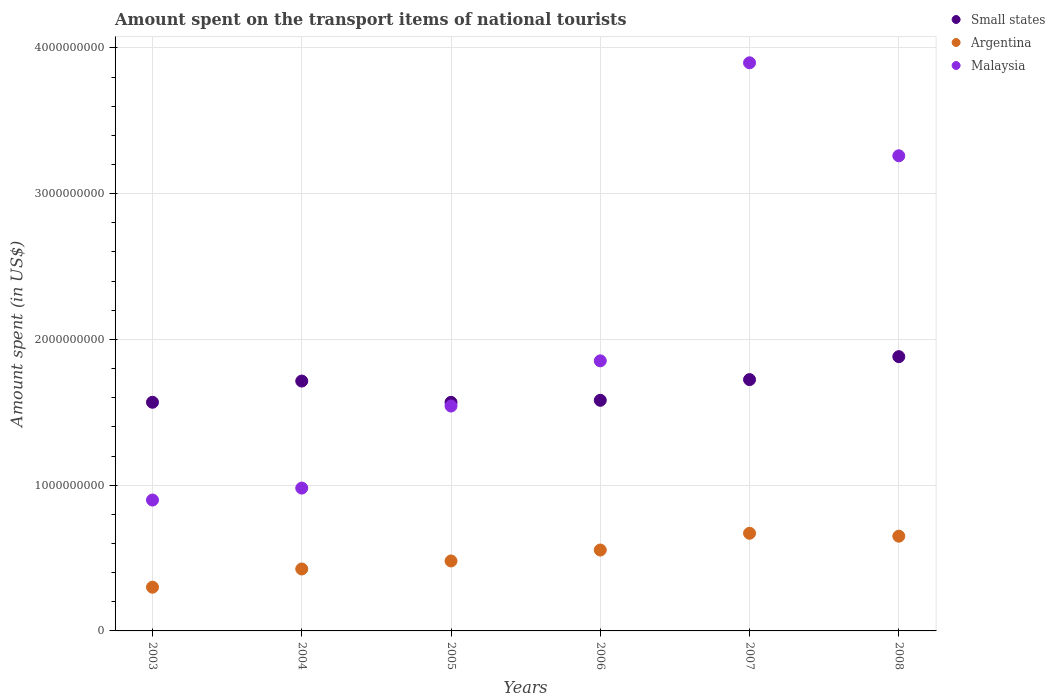What is the amount spent on the transport items of national tourists in Malaysia in 2005?
Your response must be concise. 1.54e+09. Across all years, what is the maximum amount spent on the transport items of national tourists in Small states?
Ensure brevity in your answer.  1.88e+09. Across all years, what is the minimum amount spent on the transport items of national tourists in Small states?
Ensure brevity in your answer.  1.57e+09. In which year was the amount spent on the transport items of national tourists in Argentina maximum?
Give a very brief answer. 2007. What is the total amount spent on the transport items of national tourists in Malaysia in the graph?
Keep it short and to the point. 1.24e+1. What is the difference between the amount spent on the transport items of national tourists in Small states in 2005 and that in 2008?
Offer a terse response. -3.14e+08. What is the difference between the amount spent on the transport items of national tourists in Argentina in 2006 and the amount spent on the transport items of national tourists in Small states in 2003?
Give a very brief answer. -1.01e+09. What is the average amount spent on the transport items of national tourists in Small states per year?
Keep it short and to the point. 1.67e+09. In the year 2005, what is the difference between the amount spent on the transport items of national tourists in Small states and amount spent on the transport items of national tourists in Argentina?
Give a very brief answer. 1.09e+09. What is the ratio of the amount spent on the transport items of national tourists in Malaysia in 2003 to that in 2006?
Provide a short and direct response. 0.48. Is the amount spent on the transport items of national tourists in Small states in 2003 less than that in 2007?
Offer a terse response. Yes. Is the difference between the amount spent on the transport items of national tourists in Small states in 2005 and 2007 greater than the difference between the amount spent on the transport items of national tourists in Argentina in 2005 and 2007?
Offer a very short reply. Yes. What is the difference between the highest and the lowest amount spent on the transport items of national tourists in Small states?
Provide a succinct answer. 3.14e+08. Is it the case that in every year, the sum of the amount spent on the transport items of national tourists in Small states and amount spent on the transport items of national tourists in Malaysia  is greater than the amount spent on the transport items of national tourists in Argentina?
Offer a very short reply. Yes. Does the amount spent on the transport items of national tourists in Argentina monotonically increase over the years?
Make the answer very short. No. Is the amount spent on the transport items of national tourists in Argentina strictly greater than the amount spent on the transport items of national tourists in Malaysia over the years?
Ensure brevity in your answer.  No. Is the amount spent on the transport items of national tourists in Argentina strictly less than the amount spent on the transport items of national tourists in Small states over the years?
Your answer should be compact. Yes. How many dotlines are there?
Make the answer very short. 3. Does the graph contain any zero values?
Ensure brevity in your answer.  No. Where does the legend appear in the graph?
Provide a succinct answer. Top right. How many legend labels are there?
Provide a succinct answer. 3. How are the legend labels stacked?
Your answer should be compact. Vertical. What is the title of the graph?
Provide a short and direct response. Amount spent on the transport items of national tourists. What is the label or title of the X-axis?
Provide a short and direct response. Years. What is the label or title of the Y-axis?
Give a very brief answer. Amount spent (in US$). What is the Amount spent (in US$) in Small states in 2003?
Provide a short and direct response. 1.57e+09. What is the Amount spent (in US$) in Argentina in 2003?
Your answer should be compact. 3.00e+08. What is the Amount spent (in US$) in Malaysia in 2003?
Provide a succinct answer. 8.98e+08. What is the Amount spent (in US$) of Small states in 2004?
Your response must be concise. 1.71e+09. What is the Amount spent (in US$) of Argentina in 2004?
Make the answer very short. 4.25e+08. What is the Amount spent (in US$) of Malaysia in 2004?
Your answer should be very brief. 9.80e+08. What is the Amount spent (in US$) in Small states in 2005?
Your response must be concise. 1.57e+09. What is the Amount spent (in US$) of Argentina in 2005?
Offer a terse response. 4.80e+08. What is the Amount spent (in US$) of Malaysia in 2005?
Ensure brevity in your answer.  1.54e+09. What is the Amount spent (in US$) in Small states in 2006?
Keep it short and to the point. 1.58e+09. What is the Amount spent (in US$) of Argentina in 2006?
Provide a succinct answer. 5.55e+08. What is the Amount spent (in US$) of Malaysia in 2006?
Your response must be concise. 1.85e+09. What is the Amount spent (in US$) of Small states in 2007?
Provide a succinct answer. 1.72e+09. What is the Amount spent (in US$) of Argentina in 2007?
Your answer should be very brief. 6.70e+08. What is the Amount spent (in US$) in Malaysia in 2007?
Make the answer very short. 3.90e+09. What is the Amount spent (in US$) in Small states in 2008?
Ensure brevity in your answer.  1.88e+09. What is the Amount spent (in US$) in Argentina in 2008?
Your answer should be very brief. 6.50e+08. What is the Amount spent (in US$) in Malaysia in 2008?
Keep it short and to the point. 3.26e+09. Across all years, what is the maximum Amount spent (in US$) in Small states?
Make the answer very short. 1.88e+09. Across all years, what is the maximum Amount spent (in US$) of Argentina?
Your answer should be compact. 6.70e+08. Across all years, what is the maximum Amount spent (in US$) in Malaysia?
Provide a short and direct response. 3.90e+09. Across all years, what is the minimum Amount spent (in US$) in Small states?
Offer a terse response. 1.57e+09. Across all years, what is the minimum Amount spent (in US$) in Argentina?
Give a very brief answer. 3.00e+08. Across all years, what is the minimum Amount spent (in US$) in Malaysia?
Provide a succinct answer. 8.98e+08. What is the total Amount spent (in US$) of Small states in the graph?
Give a very brief answer. 1.00e+1. What is the total Amount spent (in US$) of Argentina in the graph?
Provide a succinct answer. 3.08e+09. What is the total Amount spent (in US$) of Malaysia in the graph?
Your answer should be compact. 1.24e+1. What is the difference between the Amount spent (in US$) of Small states in 2003 and that in 2004?
Your response must be concise. -1.45e+08. What is the difference between the Amount spent (in US$) in Argentina in 2003 and that in 2004?
Give a very brief answer. -1.25e+08. What is the difference between the Amount spent (in US$) in Malaysia in 2003 and that in 2004?
Offer a terse response. -8.20e+07. What is the difference between the Amount spent (in US$) of Small states in 2003 and that in 2005?
Make the answer very short. 5.74e+05. What is the difference between the Amount spent (in US$) of Argentina in 2003 and that in 2005?
Offer a terse response. -1.80e+08. What is the difference between the Amount spent (in US$) of Malaysia in 2003 and that in 2005?
Make the answer very short. -6.45e+08. What is the difference between the Amount spent (in US$) of Small states in 2003 and that in 2006?
Make the answer very short. -1.35e+07. What is the difference between the Amount spent (in US$) of Argentina in 2003 and that in 2006?
Provide a short and direct response. -2.55e+08. What is the difference between the Amount spent (in US$) of Malaysia in 2003 and that in 2006?
Keep it short and to the point. -9.55e+08. What is the difference between the Amount spent (in US$) of Small states in 2003 and that in 2007?
Provide a succinct answer. -1.55e+08. What is the difference between the Amount spent (in US$) in Argentina in 2003 and that in 2007?
Your response must be concise. -3.70e+08. What is the difference between the Amount spent (in US$) in Malaysia in 2003 and that in 2007?
Ensure brevity in your answer.  -3.00e+09. What is the difference between the Amount spent (in US$) of Small states in 2003 and that in 2008?
Provide a succinct answer. -3.13e+08. What is the difference between the Amount spent (in US$) in Argentina in 2003 and that in 2008?
Give a very brief answer. -3.50e+08. What is the difference between the Amount spent (in US$) of Malaysia in 2003 and that in 2008?
Your response must be concise. -2.36e+09. What is the difference between the Amount spent (in US$) of Small states in 2004 and that in 2005?
Provide a short and direct response. 1.46e+08. What is the difference between the Amount spent (in US$) of Argentina in 2004 and that in 2005?
Ensure brevity in your answer.  -5.50e+07. What is the difference between the Amount spent (in US$) in Malaysia in 2004 and that in 2005?
Provide a succinct answer. -5.63e+08. What is the difference between the Amount spent (in US$) in Small states in 2004 and that in 2006?
Keep it short and to the point. 1.32e+08. What is the difference between the Amount spent (in US$) in Argentina in 2004 and that in 2006?
Keep it short and to the point. -1.30e+08. What is the difference between the Amount spent (in US$) of Malaysia in 2004 and that in 2006?
Your response must be concise. -8.73e+08. What is the difference between the Amount spent (in US$) of Small states in 2004 and that in 2007?
Your answer should be very brief. -9.98e+06. What is the difference between the Amount spent (in US$) in Argentina in 2004 and that in 2007?
Your answer should be very brief. -2.45e+08. What is the difference between the Amount spent (in US$) of Malaysia in 2004 and that in 2007?
Give a very brief answer. -2.92e+09. What is the difference between the Amount spent (in US$) of Small states in 2004 and that in 2008?
Provide a short and direct response. -1.68e+08. What is the difference between the Amount spent (in US$) of Argentina in 2004 and that in 2008?
Keep it short and to the point. -2.25e+08. What is the difference between the Amount spent (in US$) in Malaysia in 2004 and that in 2008?
Provide a short and direct response. -2.28e+09. What is the difference between the Amount spent (in US$) of Small states in 2005 and that in 2006?
Keep it short and to the point. -1.40e+07. What is the difference between the Amount spent (in US$) of Argentina in 2005 and that in 2006?
Provide a succinct answer. -7.50e+07. What is the difference between the Amount spent (in US$) in Malaysia in 2005 and that in 2006?
Offer a terse response. -3.10e+08. What is the difference between the Amount spent (in US$) of Small states in 2005 and that in 2007?
Give a very brief answer. -1.56e+08. What is the difference between the Amount spent (in US$) of Argentina in 2005 and that in 2007?
Your answer should be very brief. -1.90e+08. What is the difference between the Amount spent (in US$) of Malaysia in 2005 and that in 2007?
Your answer should be very brief. -2.36e+09. What is the difference between the Amount spent (in US$) in Small states in 2005 and that in 2008?
Give a very brief answer. -3.14e+08. What is the difference between the Amount spent (in US$) of Argentina in 2005 and that in 2008?
Offer a terse response. -1.70e+08. What is the difference between the Amount spent (in US$) of Malaysia in 2005 and that in 2008?
Make the answer very short. -1.72e+09. What is the difference between the Amount spent (in US$) of Small states in 2006 and that in 2007?
Make the answer very short. -1.42e+08. What is the difference between the Amount spent (in US$) in Argentina in 2006 and that in 2007?
Provide a succinct answer. -1.15e+08. What is the difference between the Amount spent (in US$) of Malaysia in 2006 and that in 2007?
Make the answer very short. -2.04e+09. What is the difference between the Amount spent (in US$) in Small states in 2006 and that in 2008?
Keep it short and to the point. -3.00e+08. What is the difference between the Amount spent (in US$) of Argentina in 2006 and that in 2008?
Ensure brevity in your answer.  -9.50e+07. What is the difference between the Amount spent (in US$) of Malaysia in 2006 and that in 2008?
Provide a short and direct response. -1.41e+09. What is the difference between the Amount spent (in US$) of Small states in 2007 and that in 2008?
Your answer should be very brief. -1.58e+08. What is the difference between the Amount spent (in US$) of Malaysia in 2007 and that in 2008?
Your response must be concise. 6.38e+08. What is the difference between the Amount spent (in US$) of Small states in 2003 and the Amount spent (in US$) of Argentina in 2004?
Ensure brevity in your answer.  1.14e+09. What is the difference between the Amount spent (in US$) in Small states in 2003 and the Amount spent (in US$) in Malaysia in 2004?
Ensure brevity in your answer.  5.89e+08. What is the difference between the Amount spent (in US$) of Argentina in 2003 and the Amount spent (in US$) of Malaysia in 2004?
Your response must be concise. -6.80e+08. What is the difference between the Amount spent (in US$) in Small states in 2003 and the Amount spent (in US$) in Argentina in 2005?
Make the answer very short. 1.09e+09. What is the difference between the Amount spent (in US$) of Small states in 2003 and the Amount spent (in US$) of Malaysia in 2005?
Your answer should be compact. 2.58e+07. What is the difference between the Amount spent (in US$) in Argentina in 2003 and the Amount spent (in US$) in Malaysia in 2005?
Provide a short and direct response. -1.24e+09. What is the difference between the Amount spent (in US$) in Small states in 2003 and the Amount spent (in US$) in Argentina in 2006?
Offer a very short reply. 1.01e+09. What is the difference between the Amount spent (in US$) in Small states in 2003 and the Amount spent (in US$) in Malaysia in 2006?
Your answer should be very brief. -2.84e+08. What is the difference between the Amount spent (in US$) of Argentina in 2003 and the Amount spent (in US$) of Malaysia in 2006?
Keep it short and to the point. -1.55e+09. What is the difference between the Amount spent (in US$) in Small states in 2003 and the Amount spent (in US$) in Argentina in 2007?
Ensure brevity in your answer.  8.99e+08. What is the difference between the Amount spent (in US$) in Small states in 2003 and the Amount spent (in US$) in Malaysia in 2007?
Offer a very short reply. -2.33e+09. What is the difference between the Amount spent (in US$) in Argentina in 2003 and the Amount spent (in US$) in Malaysia in 2007?
Ensure brevity in your answer.  -3.60e+09. What is the difference between the Amount spent (in US$) of Small states in 2003 and the Amount spent (in US$) of Argentina in 2008?
Keep it short and to the point. 9.19e+08. What is the difference between the Amount spent (in US$) of Small states in 2003 and the Amount spent (in US$) of Malaysia in 2008?
Give a very brief answer. -1.69e+09. What is the difference between the Amount spent (in US$) of Argentina in 2003 and the Amount spent (in US$) of Malaysia in 2008?
Keep it short and to the point. -2.96e+09. What is the difference between the Amount spent (in US$) in Small states in 2004 and the Amount spent (in US$) in Argentina in 2005?
Your answer should be compact. 1.23e+09. What is the difference between the Amount spent (in US$) of Small states in 2004 and the Amount spent (in US$) of Malaysia in 2005?
Offer a terse response. 1.71e+08. What is the difference between the Amount spent (in US$) of Argentina in 2004 and the Amount spent (in US$) of Malaysia in 2005?
Keep it short and to the point. -1.12e+09. What is the difference between the Amount spent (in US$) in Small states in 2004 and the Amount spent (in US$) in Argentina in 2006?
Offer a terse response. 1.16e+09. What is the difference between the Amount spent (in US$) in Small states in 2004 and the Amount spent (in US$) in Malaysia in 2006?
Keep it short and to the point. -1.39e+08. What is the difference between the Amount spent (in US$) in Argentina in 2004 and the Amount spent (in US$) in Malaysia in 2006?
Provide a succinct answer. -1.43e+09. What is the difference between the Amount spent (in US$) of Small states in 2004 and the Amount spent (in US$) of Argentina in 2007?
Give a very brief answer. 1.04e+09. What is the difference between the Amount spent (in US$) in Small states in 2004 and the Amount spent (in US$) in Malaysia in 2007?
Give a very brief answer. -2.18e+09. What is the difference between the Amount spent (in US$) in Argentina in 2004 and the Amount spent (in US$) in Malaysia in 2007?
Your answer should be compact. -3.47e+09. What is the difference between the Amount spent (in US$) in Small states in 2004 and the Amount spent (in US$) in Argentina in 2008?
Make the answer very short. 1.06e+09. What is the difference between the Amount spent (in US$) in Small states in 2004 and the Amount spent (in US$) in Malaysia in 2008?
Provide a succinct answer. -1.55e+09. What is the difference between the Amount spent (in US$) in Argentina in 2004 and the Amount spent (in US$) in Malaysia in 2008?
Provide a succinct answer. -2.84e+09. What is the difference between the Amount spent (in US$) in Small states in 2005 and the Amount spent (in US$) in Argentina in 2006?
Your answer should be compact. 1.01e+09. What is the difference between the Amount spent (in US$) in Small states in 2005 and the Amount spent (in US$) in Malaysia in 2006?
Offer a terse response. -2.85e+08. What is the difference between the Amount spent (in US$) of Argentina in 2005 and the Amount spent (in US$) of Malaysia in 2006?
Keep it short and to the point. -1.37e+09. What is the difference between the Amount spent (in US$) in Small states in 2005 and the Amount spent (in US$) in Argentina in 2007?
Provide a short and direct response. 8.98e+08. What is the difference between the Amount spent (in US$) of Small states in 2005 and the Amount spent (in US$) of Malaysia in 2007?
Offer a terse response. -2.33e+09. What is the difference between the Amount spent (in US$) of Argentina in 2005 and the Amount spent (in US$) of Malaysia in 2007?
Offer a very short reply. -3.42e+09. What is the difference between the Amount spent (in US$) of Small states in 2005 and the Amount spent (in US$) of Argentina in 2008?
Give a very brief answer. 9.18e+08. What is the difference between the Amount spent (in US$) of Small states in 2005 and the Amount spent (in US$) of Malaysia in 2008?
Give a very brief answer. -1.69e+09. What is the difference between the Amount spent (in US$) of Argentina in 2005 and the Amount spent (in US$) of Malaysia in 2008?
Offer a terse response. -2.78e+09. What is the difference between the Amount spent (in US$) of Small states in 2006 and the Amount spent (in US$) of Argentina in 2007?
Make the answer very short. 9.12e+08. What is the difference between the Amount spent (in US$) of Small states in 2006 and the Amount spent (in US$) of Malaysia in 2007?
Provide a short and direct response. -2.32e+09. What is the difference between the Amount spent (in US$) of Argentina in 2006 and the Amount spent (in US$) of Malaysia in 2007?
Keep it short and to the point. -3.34e+09. What is the difference between the Amount spent (in US$) in Small states in 2006 and the Amount spent (in US$) in Argentina in 2008?
Make the answer very short. 9.32e+08. What is the difference between the Amount spent (in US$) in Small states in 2006 and the Amount spent (in US$) in Malaysia in 2008?
Provide a short and direct response. -1.68e+09. What is the difference between the Amount spent (in US$) of Argentina in 2006 and the Amount spent (in US$) of Malaysia in 2008?
Give a very brief answer. -2.70e+09. What is the difference between the Amount spent (in US$) in Small states in 2007 and the Amount spent (in US$) in Argentina in 2008?
Make the answer very short. 1.07e+09. What is the difference between the Amount spent (in US$) in Small states in 2007 and the Amount spent (in US$) in Malaysia in 2008?
Ensure brevity in your answer.  -1.54e+09. What is the difference between the Amount spent (in US$) in Argentina in 2007 and the Amount spent (in US$) in Malaysia in 2008?
Make the answer very short. -2.59e+09. What is the average Amount spent (in US$) in Small states per year?
Your response must be concise. 1.67e+09. What is the average Amount spent (in US$) in Argentina per year?
Keep it short and to the point. 5.13e+08. What is the average Amount spent (in US$) of Malaysia per year?
Offer a very short reply. 2.07e+09. In the year 2003, what is the difference between the Amount spent (in US$) of Small states and Amount spent (in US$) of Argentina?
Your answer should be compact. 1.27e+09. In the year 2003, what is the difference between the Amount spent (in US$) in Small states and Amount spent (in US$) in Malaysia?
Ensure brevity in your answer.  6.71e+08. In the year 2003, what is the difference between the Amount spent (in US$) of Argentina and Amount spent (in US$) of Malaysia?
Make the answer very short. -5.98e+08. In the year 2004, what is the difference between the Amount spent (in US$) of Small states and Amount spent (in US$) of Argentina?
Keep it short and to the point. 1.29e+09. In the year 2004, what is the difference between the Amount spent (in US$) of Small states and Amount spent (in US$) of Malaysia?
Your response must be concise. 7.34e+08. In the year 2004, what is the difference between the Amount spent (in US$) of Argentina and Amount spent (in US$) of Malaysia?
Your response must be concise. -5.55e+08. In the year 2005, what is the difference between the Amount spent (in US$) of Small states and Amount spent (in US$) of Argentina?
Keep it short and to the point. 1.09e+09. In the year 2005, what is the difference between the Amount spent (in US$) of Small states and Amount spent (in US$) of Malaysia?
Ensure brevity in your answer.  2.53e+07. In the year 2005, what is the difference between the Amount spent (in US$) in Argentina and Amount spent (in US$) in Malaysia?
Provide a short and direct response. -1.06e+09. In the year 2006, what is the difference between the Amount spent (in US$) of Small states and Amount spent (in US$) of Argentina?
Your answer should be compact. 1.03e+09. In the year 2006, what is the difference between the Amount spent (in US$) in Small states and Amount spent (in US$) in Malaysia?
Keep it short and to the point. -2.71e+08. In the year 2006, what is the difference between the Amount spent (in US$) in Argentina and Amount spent (in US$) in Malaysia?
Make the answer very short. -1.30e+09. In the year 2007, what is the difference between the Amount spent (in US$) of Small states and Amount spent (in US$) of Argentina?
Keep it short and to the point. 1.05e+09. In the year 2007, what is the difference between the Amount spent (in US$) in Small states and Amount spent (in US$) in Malaysia?
Make the answer very short. -2.17e+09. In the year 2007, what is the difference between the Amount spent (in US$) of Argentina and Amount spent (in US$) of Malaysia?
Your answer should be very brief. -3.23e+09. In the year 2008, what is the difference between the Amount spent (in US$) of Small states and Amount spent (in US$) of Argentina?
Your answer should be very brief. 1.23e+09. In the year 2008, what is the difference between the Amount spent (in US$) in Small states and Amount spent (in US$) in Malaysia?
Offer a very short reply. -1.38e+09. In the year 2008, what is the difference between the Amount spent (in US$) of Argentina and Amount spent (in US$) of Malaysia?
Offer a very short reply. -2.61e+09. What is the ratio of the Amount spent (in US$) of Small states in 2003 to that in 2004?
Keep it short and to the point. 0.92. What is the ratio of the Amount spent (in US$) in Argentina in 2003 to that in 2004?
Your response must be concise. 0.71. What is the ratio of the Amount spent (in US$) of Malaysia in 2003 to that in 2004?
Your answer should be compact. 0.92. What is the ratio of the Amount spent (in US$) of Small states in 2003 to that in 2005?
Give a very brief answer. 1. What is the ratio of the Amount spent (in US$) of Malaysia in 2003 to that in 2005?
Your answer should be very brief. 0.58. What is the ratio of the Amount spent (in US$) in Small states in 2003 to that in 2006?
Provide a short and direct response. 0.99. What is the ratio of the Amount spent (in US$) in Argentina in 2003 to that in 2006?
Your answer should be compact. 0.54. What is the ratio of the Amount spent (in US$) of Malaysia in 2003 to that in 2006?
Keep it short and to the point. 0.48. What is the ratio of the Amount spent (in US$) of Small states in 2003 to that in 2007?
Keep it short and to the point. 0.91. What is the ratio of the Amount spent (in US$) of Argentina in 2003 to that in 2007?
Offer a very short reply. 0.45. What is the ratio of the Amount spent (in US$) of Malaysia in 2003 to that in 2007?
Offer a terse response. 0.23. What is the ratio of the Amount spent (in US$) in Small states in 2003 to that in 2008?
Keep it short and to the point. 0.83. What is the ratio of the Amount spent (in US$) of Argentina in 2003 to that in 2008?
Your answer should be compact. 0.46. What is the ratio of the Amount spent (in US$) in Malaysia in 2003 to that in 2008?
Offer a terse response. 0.28. What is the ratio of the Amount spent (in US$) of Small states in 2004 to that in 2005?
Ensure brevity in your answer.  1.09. What is the ratio of the Amount spent (in US$) of Argentina in 2004 to that in 2005?
Keep it short and to the point. 0.89. What is the ratio of the Amount spent (in US$) in Malaysia in 2004 to that in 2005?
Provide a short and direct response. 0.64. What is the ratio of the Amount spent (in US$) in Small states in 2004 to that in 2006?
Provide a succinct answer. 1.08. What is the ratio of the Amount spent (in US$) of Argentina in 2004 to that in 2006?
Provide a short and direct response. 0.77. What is the ratio of the Amount spent (in US$) in Malaysia in 2004 to that in 2006?
Your response must be concise. 0.53. What is the ratio of the Amount spent (in US$) in Argentina in 2004 to that in 2007?
Keep it short and to the point. 0.63. What is the ratio of the Amount spent (in US$) in Malaysia in 2004 to that in 2007?
Provide a succinct answer. 0.25. What is the ratio of the Amount spent (in US$) of Small states in 2004 to that in 2008?
Offer a very short reply. 0.91. What is the ratio of the Amount spent (in US$) in Argentina in 2004 to that in 2008?
Give a very brief answer. 0.65. What is the ratio of the Amount spent (in US$) of Malaysia in 2004 to that in 2008?
Your response must be concise. 0.3. What is the ratio of the Amount spent (in US$) of Argentina in 2005 to that in 2006?
Provide a succinct answer. 0.86. What is the ratio of the Amount spent (in US$) in Malaysia in 2005 to that in 2006?
Provide a succinct answer. 0.83. What is the ratio of the Amount spent (in US$) of Small states in 2005 to that in 2007?
Offer a terse response. 0.91. What is the ratio of the Amount spent (in US$) of Argentina in 2005 to that in 2007?
Provide a short and direct response. 0.72. What is the ratio of the Amount spent (in US$) of Malaysia in 2005 to that in 2007?
Your response must be concise. 0.4. What is the ratio of the Amount spent (in US$) of Small states in 2005 to that in 2008?
Your answer should be compact. 0.83. What is the ratio of the Amount spent (in US$) in Argentina in 2005 to that in 2008?
Make the answer very short. 0.74. What is the ratio of the Amount spent (in US$) of Malaysia in 2005 to that in 2008?
Your answer should be compact. 0.47. What is the ratio of the Amount spent (in US$) of Small states in 2006 to that in 2007?
Keep it short and to the point. 0.92. What is the ratio of the Amount spent (in US$) of Argentina in 2006 to that in 2007?
Keep it short and to the point. 0.83. What is the ratio of the Amount spent (in US$) of Malaysia in 2006 to that in 2007?
Your response must be concise. 0.48. What is the ratio of the Amount spent (in US$) of Small states in 2006 to that in 2008?
Your response must be concise. 0.84. What is the ratio of the Amount spent (in US$) in Argentina in 2006 to that in 2008?
Make the answer very short. 0.85. What is the ratio of the Amount spent (in US$) of Malaysia in 2006 to that in 2008?
Offer a terse response. 0.57. What is the ratio of the Amount spent (in US$) in Small states in 2007 to that in 2008?
Your response must be concise. 0.92. What is the ratio of the Amount spent (in US$) in Argentina in 2007 to that in 2008?
Ensure brevity in your answer.  1.03. What is the ratio of the Amount spent (in US$) in Malaysia in 2007 to that in 2008?
Ensure brevity in your answer.  1.2. What is the difference between the highest and the second highest Amount spent (in US$) of Small states?
Provide a short and direct response. 1.58e+08. What is the difference between the highest and the second highest Amount spent (in US$) in Malaysia?
Ensure brevity in your answer.  6.38e+08. What is the difference between the highest and the lowest Amount spent (in US$) of Small states?
Provide a succinct answer. 3.14e+08. What is the difference between the highest and the lowest Amount spent (in US$) of Argentina?
Give a very brief answer. 3.70e+08. What is the difference between the highest and the lowest Amount spent (in US$) in Malaysia?
Make the answer very short. 3.00e+09. 